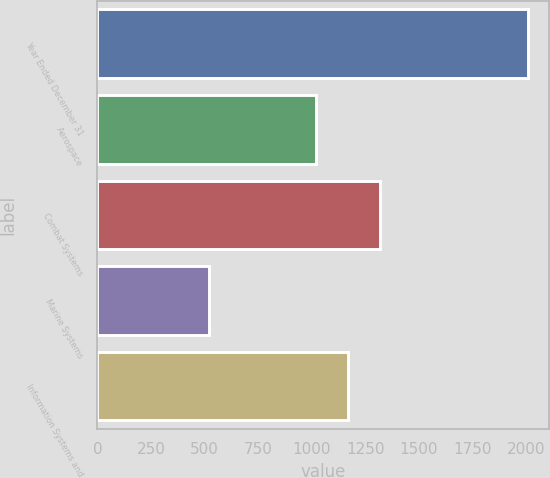Convert chart. <chart><loc_0><loc_0><loc_500><loc_500><bar_chart><fcel>Year Ended December 31<fcel>Aerospace<fcel>Combat Systems<fcel>Marine Systems<fcel>Information Systems and<nl><fcel>2008<fcel>1021<fcel>1318.4<fcel>521<fcel>1169.7<nl></chart> 